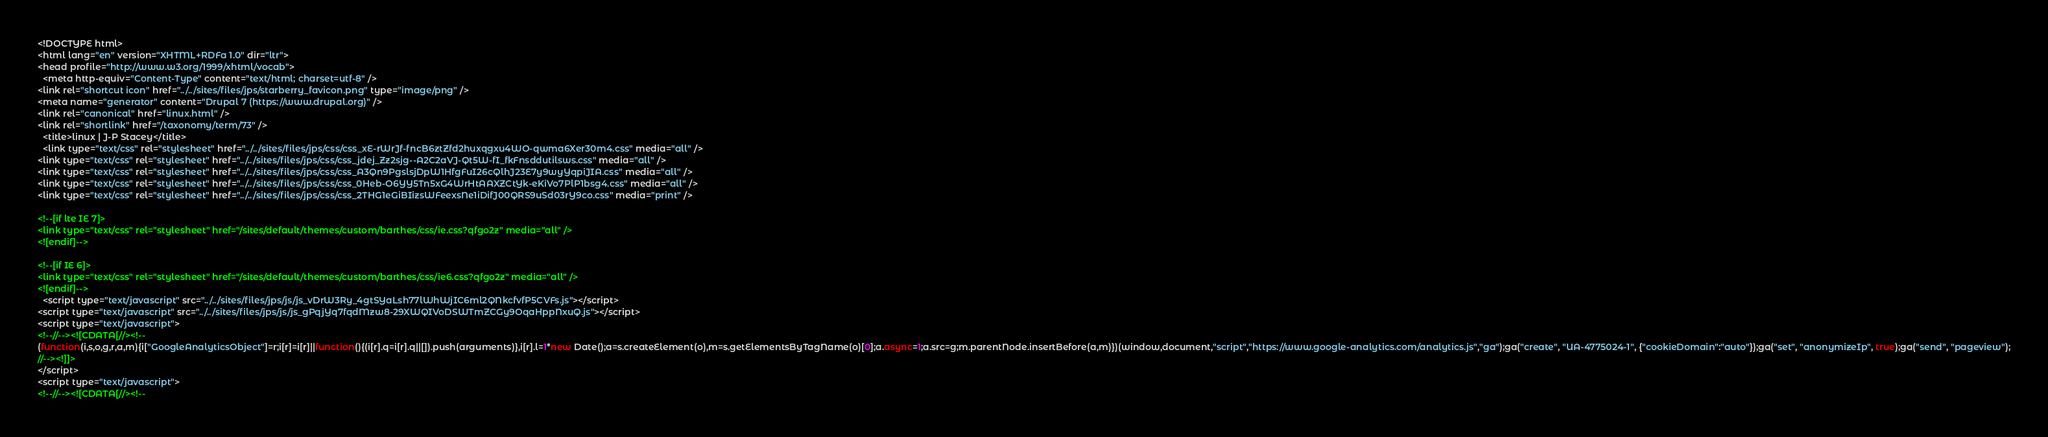Convert code to text. <code><loc_0><loc_0><loc_500><loc_500><_HTML_><!DOCTYPE html>
<html lang="en" version="XHTML+RDFa 1.0" dir="ltr">
<head profile="http://www.w3.org/1999/xhtml/vocab">
  <meta http-equiv="Content-Type" content="text/html; charset=utf-8" />
<link rel="shortcut icon" href="../../sites/files/jps/starberry_favicon.png" type="image/png" />
<meta name="generator" content="Drupal 7 (https://www.drupal.org)" />
<link rel="canonical" href="linux.html" />
<link rel="shortlink" href="/taxonomy/term/73" />
  <title>linux | J-P Stacey</title>
  <link type="text/css" rel="stylesheet" href="../../sites/files/jps/css/css_xE-rWrJf-fncB6ztZfd2huxqgxu4WO-qwma6Xer30m4.css" media="all" />
<link type="text/css" rel="stylesheet" href="../../sites/files/jps/css/css_jdej_Zz2sjg--A2C2aVJ-Qt5W-fI_fkFnsddutilsws.css" media="all" />
<link type="text/css" rel="stylesheet" href="../../sites/files/jps/css/css_A3Qn9PgslsjDpW1HfgFuI26cQlhJ23E7y9wyYqpiJIA.css" media="all" />
<link type="text/css" rel="stylesheet" href="../../sites/files/jps/css/css_0Heb-O6YY5Tn5xG4WrHtAAXZCtYk-eKiVo7PlP1bsg4.css" media="all" />
<link type="text/css" rel="stylesheet" href="../../sites/files/jps/css/css_2THG1eGiBIizsWFeexsNe1iDifJ00QRS9uSd03rY9co.css" media="print" />

<!--[if lte IE 7]>
<link type="text/css" rel="stylesheet" href="/sites/default/themes/custom/barthes/css/ie.css?qfgo2z" media="all" />
<![endif]-->

<!--[if IE 6]>
<link type="text/css" rel="stylesheet" href="/sites/default/themes/custom/barthes/css/ie6.css?qfgo2z" media="all" />
<![endif]-->
  <script type="text/javascript" src="../../sites/files/jps/js/js_vDrW3Ry_4gtSYaLsh77lWhWjIC6ml2QNkcfvfP5CVFs.js"></script>
<script type="text/javascript" src="../../sites/files/jps/js/js_gPqjYq7fqdMzw8-29XWQIVoDSWTmZCGy9OqaHppNxuQ.js"></script>
<script type="text/javascript">
<!--//--><![CDATA[//><!--
(function(i,s,o,g,r,a,m){i["GoogleAnalyticsObject"]=r;i[r]=i[r]||function(){(i[r].q=i[r].q||[]).push(arguments)},i[r].l=1*new Date();a=s.createElement(o),m=s.getElementsByTagName(o)[0];a.async=1;a.src=g;m.parentNode.insertBefore(a,m)})(window,document,"script","https://www.google-analytics.com/analytics.js","ga");ga("create", "UA-4775024-1", {"cookieDomain":"auto"});ga("set", "anonymizeIp", true);ga("send", "pageview");
//--><!]]>
</script>
<script type="text/javascript">
<!--//--><![CDATA[//><!--</code> 